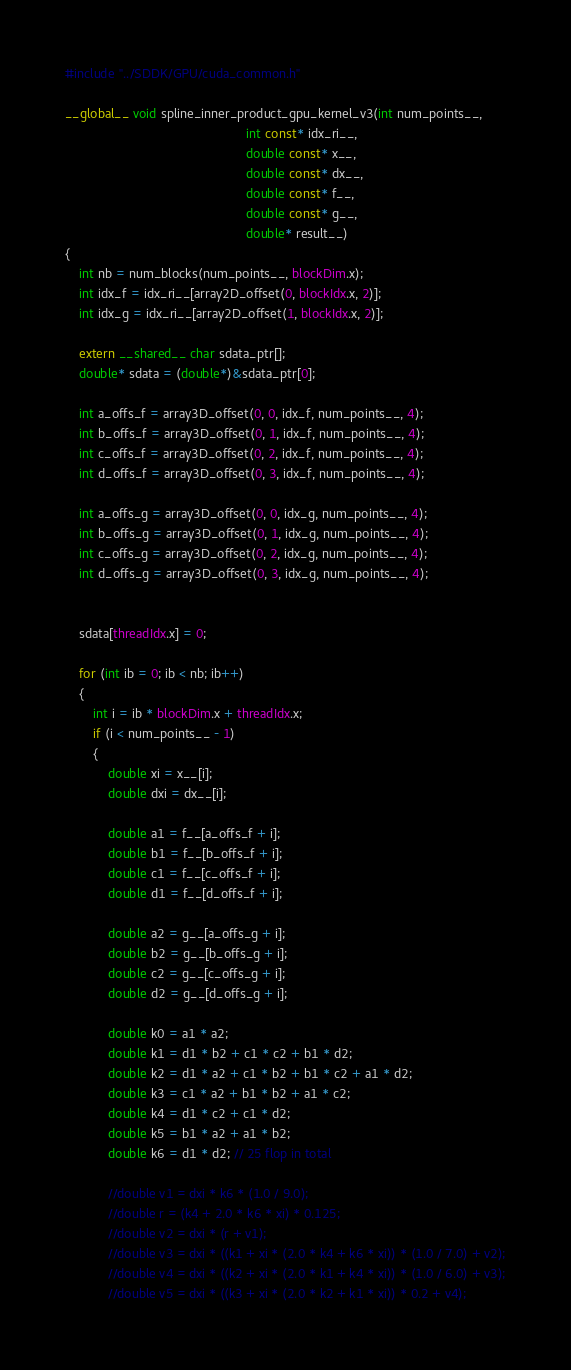Convert code to text. <code><loc_0><loc_0><loc_500><loc_500><_Cuda_>#include "../SDDK/GPU/cuda_common.h"

__global__ void spline_inner_product_gpu_kernel_v3(int num_points__,
                                                   int const* idx_ri__,
                                                   double const* x__,
                                                   double const* dx__,
                                                   double const* f__,
                                                   double const* g__,
                                                   double* result__)
{
    int nb = num_blocks(num_points__, blockDim.x);
    int idx_f = idx_ri__[array2D_offset(0, blockIdx.x, 2)];
    int idx_g = idx_ri__[array2D_offset(1, blockIdx.x, 2)];

    extern __shared__ char sdata_ptr[];
    double* sdata = (double*)&sdata_ptr[0];

    int a_offs_f = array3D_offset(0, 0, idx_f, num_points__, 4);
    int b_offs_f = array3D_offset(0, 1, idx_f, num_points__, 4);
    int c_offs_f = array3D_offset(0, 2, idx_f, num_points__, 4);
    int d_offs_f = array3D_offset(0, 3, idx_f, num_points__, 4);

    int a_offs_g = array3D_offset(0, 0, idx_g, num_points__, 4);
    int b_offs_g = array3D_offset(0, 1, idx_g, num_points__, 4);
    int c_offs_g = array3D_offset(0, 2, idx_g, num_points__, 4);
    int d_offs_g = array3D_offset(0, 3, idx_g, num_points__, 4);


    sdata[threadIdx.x] = 0;

    for (int ib = 0; ib < nb; ib++)
    {
        int i = ib * blockDim.x + threadIdx.x;
        if (i < num_points__ - 1)
        {
            double xi = x__[i];
            double dxi = dx__[i];

            double a1 = f__[a_offs_f + i];
            double b1 = f__[b_offs_f + i];
            double c1 = f__[c_offs_f + i];
            double d1 = f__[d_offs_f + i];
            
            double a2 = g__[a_offs_g + i];
            double b2 = g__[b_offs_g + i];
            double c2 = g__[c_offs_g + i];
            double d2 = g__[d_offs_g + i];
                
            double k0 = a1 * a2;
            double k1 = d1 * b2 + c1 * c2 + b1 * d2;
            double k2 = d1 * a2 + c1 * b2 + b1 * c2 + a1 * d2;
            double k3 = c1 * a2 + b1 * b2 + a1 * c2;
            double k4 = d1 * c2 + c1 * d2;
            double k5 = b1 * a2 + a1 * b2;
            double k6 = d1 * d2; // 25 flop in total

            //double v1 = dxi * k6 * (1.0 / 9.0);
            //double r = (k4 + 2.0 * k6 * xi) * 0.125;
            //double v2 = dxi * (r + v1);
            //double v3 = dxi * ((k1 + xi * (2.0 * k4 + k6 * xi)) * (1.0 / 7.0) + v2);
            //double v4 = dxi * ((k2 + xi * (2.0 * k1 + k4 * xi)) * (1.0 / 6.0) + v3);
            //double v5 = dxi * ((k3 + xi * (2.0 * k2 + k1 * xi)) * 0.2 + v4);</code> 